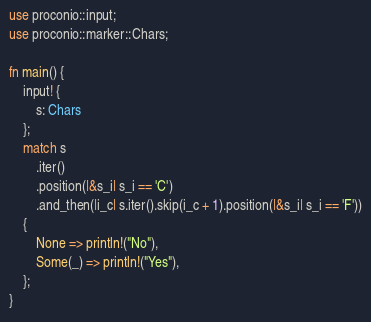Convert code to text. <code><loc_0><loc_0><loc_500><loc_500><_Rust_>use proconio::input;
use proconio::marker::Chars;

fn main() {
    input! {
        s: Chars
    };
    match s
        .iter()
        .position(|&s_i| s_i == 'C')
        .and_then(|i_c| s.iter().skip(i_c + 1).position(|&s_i| s_i == 'F'))
    {
        None => println!("No"),
        Some(_) => println!("Yes"),
    };
}
</code> 